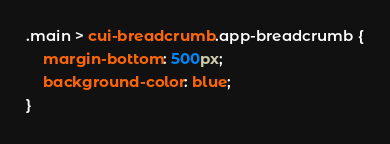<code> <loc_0><loc_0><loc_500><loc_500><_CSS_>.main > cui-breadcrumb.app-breadcrumb {
    margin-bottom: 500px;
    background-color: blue;
}</code> 